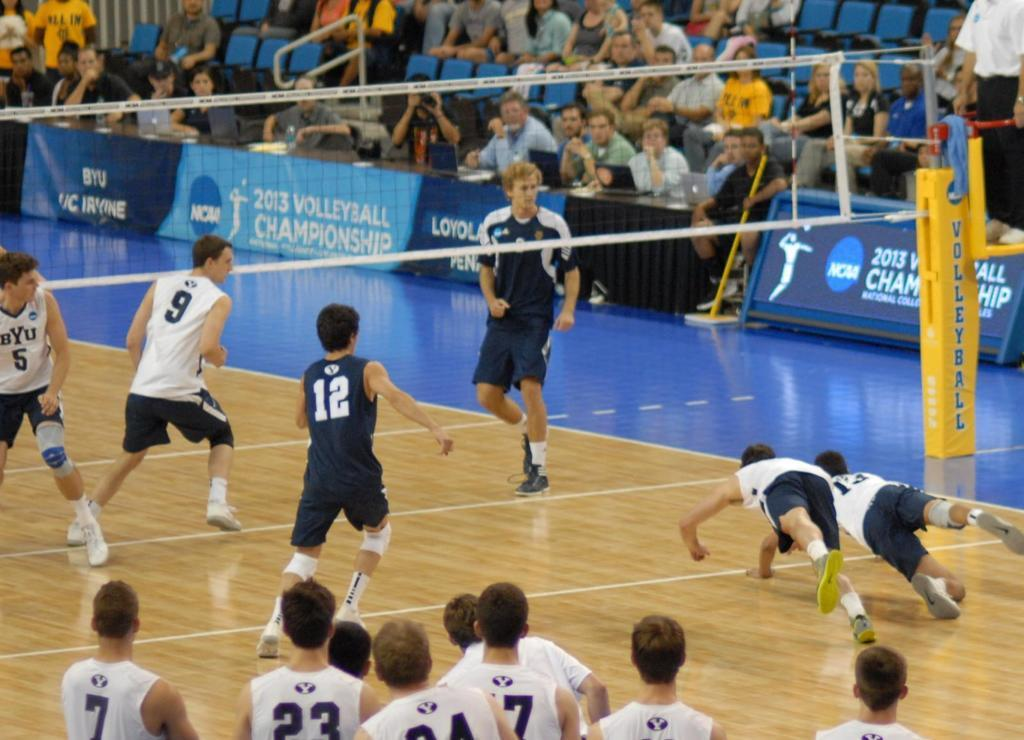How many people are in the image? There is a group of people in the image, but the exact number is not specified. What are the people doing in the image? Some people are on the ground, and some people are sitting on chairs. What object is present in the image that might be used for a game or sport? There is a net in the image, which could be used for various games or sports. What decorative elements are present in the image? There are banners in the image. What type of mitten is being used to play with the steel in the image? There is no mitten or steel present in the image. 